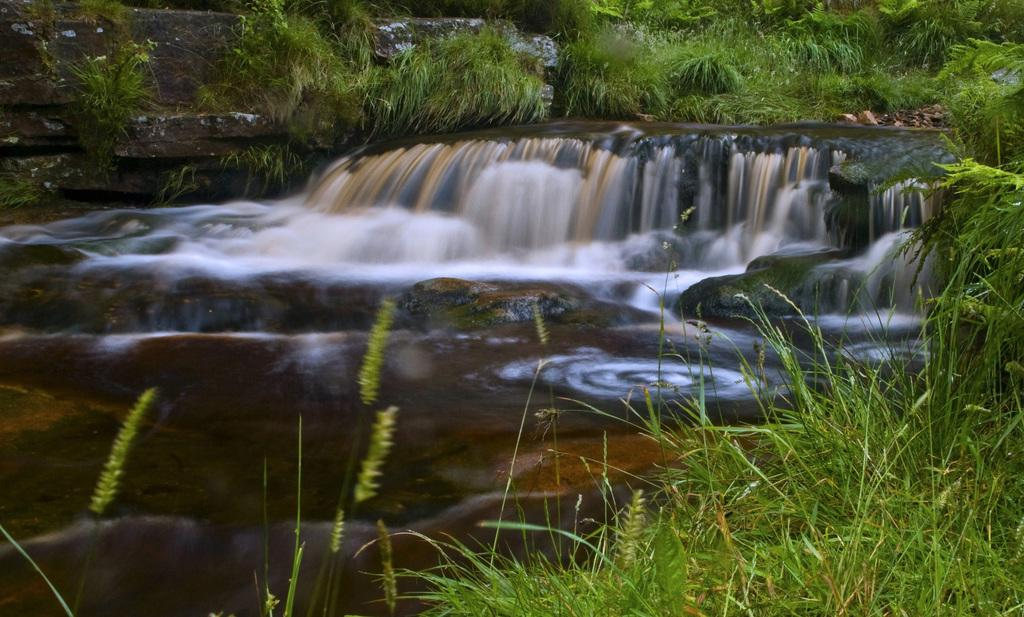What is the main feature in the middle of the image? There are waterfalls in the middle of the image. What can be seen at the bottom of the image? At the bottom of the image, there are plants, grass, stones, and water. What is present at the top of the image? At the top of the image, there are plants, grass, and stones. How many clocks are visible in the image? There are no clocks present in the image. What type of lumber is being used to construct the waterfalls in the image? The waterfalls are natural formations and do not involve any lumber or construction. 